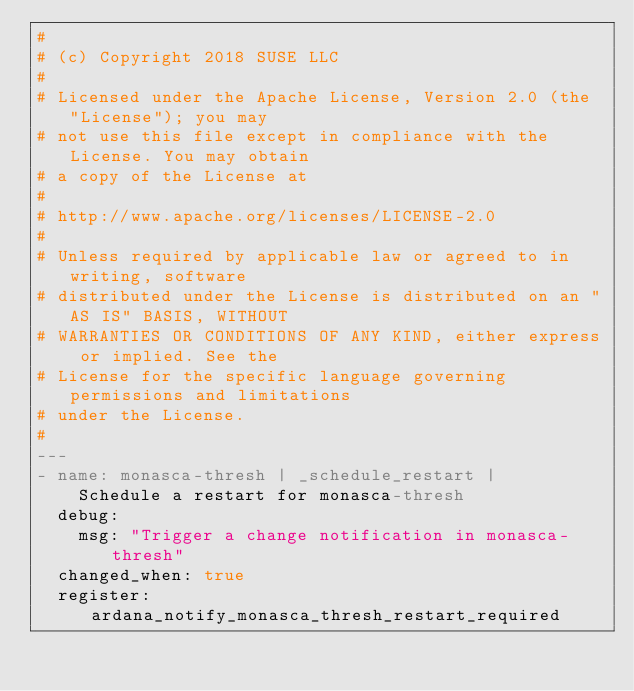Convert code to text. <code><loc_0><loc_0><loc_500><loc_500><_YAML_>#
# (c) Copyright 2018 SUSE LLC
#
# Licensed under the Apache License, Version 2.0 (the "License"); you may
# not use this file except in compliance with the License. You may obtain
# a copy of the License at
#
# http://www.apache.org/licenses/LICENSE-2.0
#
# Unless required by applicable law or agreed to in writing, software
# distributed under the License is distributed on an "AS IS" BASIS, WITHOUT
# WARRANTIES OR CONDITIONS OF ANY KIND, either express or implied. See the
# License for the specific language governing permissions and limitations
# under the License.
#
---
- name: monasca-thresh | _schedule_restart |
    Schedule a restart for monasca-thresh
  debug:
    msg: "Trigger a change notification in monasca-thresh"
  changed_when: true
  register: ardana_notify_monasca_thresh_restart_required</code> 